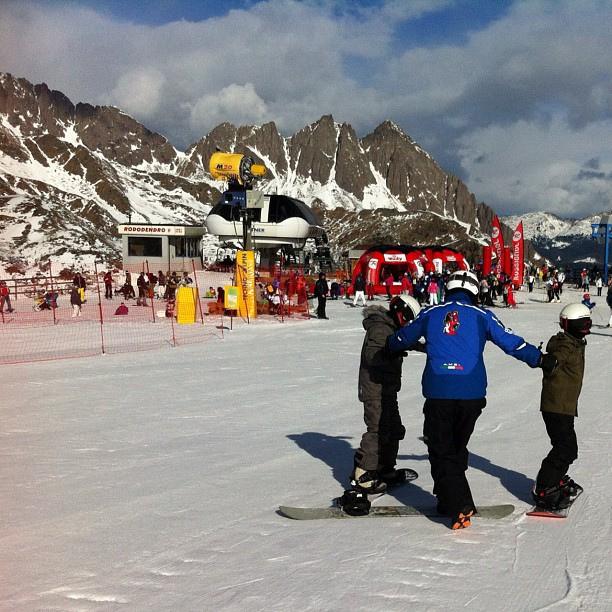Is it very cold there?
Short answer required. Yes. Is the snow deep?
Concise answer only. No. What game are they playing?
Answer briefly. Snowboarding. What color is the netted slope barrier?
Write a very short answer. Red. What kind of event is happening?
Give a very brief answer. Snowboarding. How many people are in the background?
Concise answer only. Lot. What are the people doing?
Give a very brief answer. Snowboarding. What sport are they participating in?
Write a very short answer. Snowboarding. Is this an advertisement?
Concise answer only. No. 